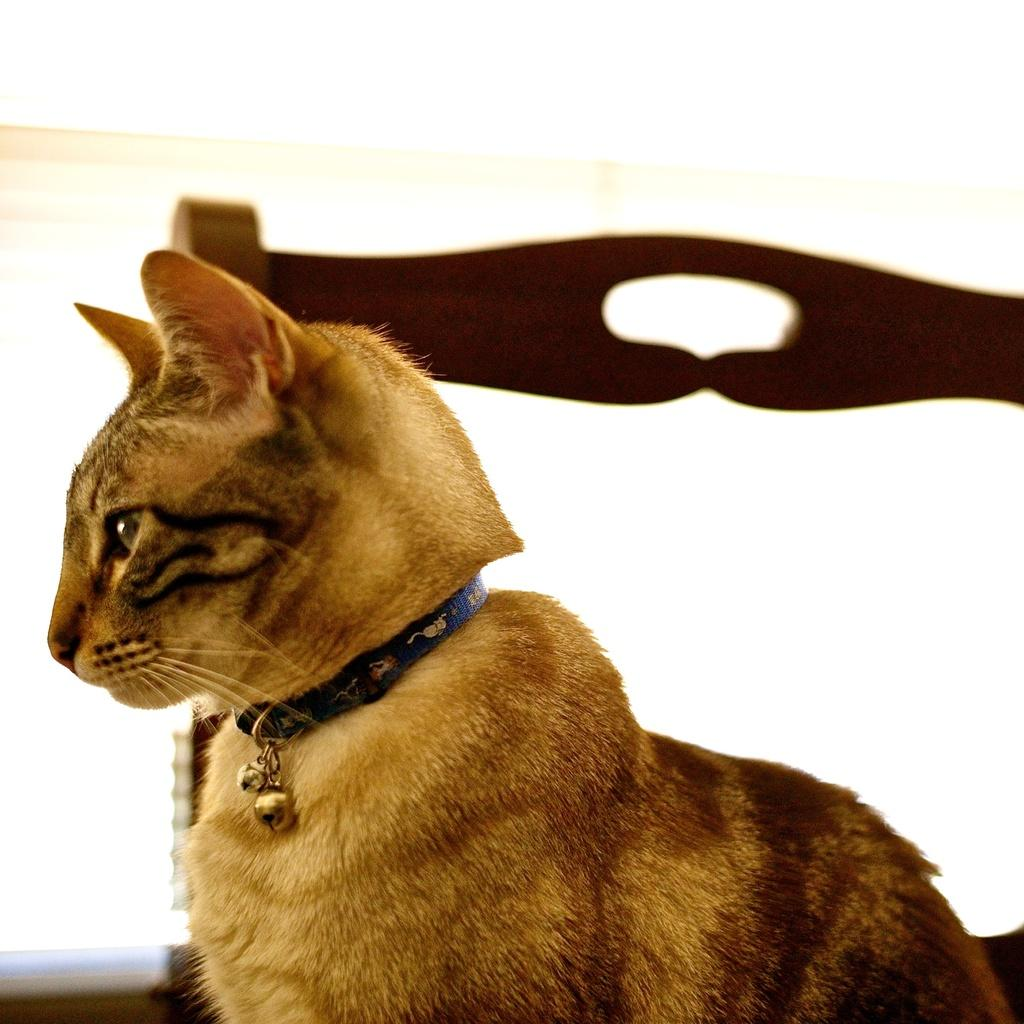What type of animal is in the image? There is a cat in the image. Where is the cat located in the image? The cat is in a chair. What type of bomb can be seen in the image? There is no bomb present in the image; it features a cat in a chair. What season is depicted in the image? The image does not depict a specific season, so it cannot be determined from the image. 